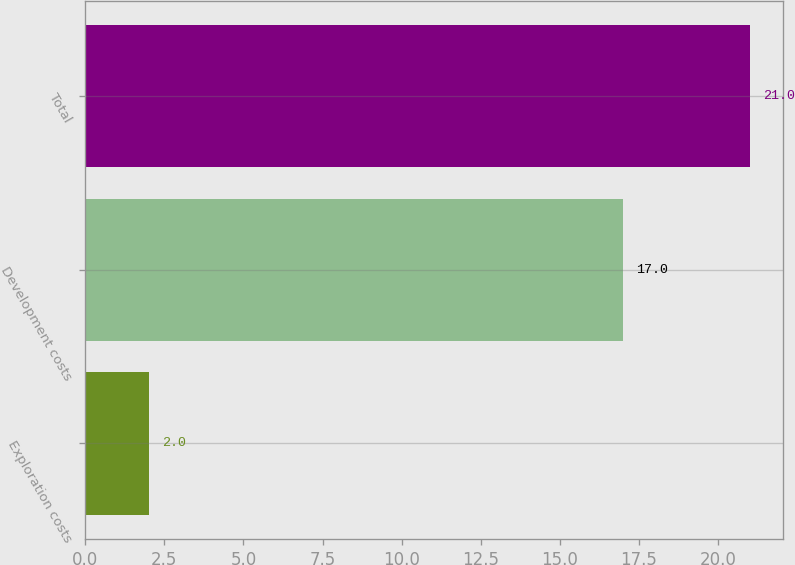Convert chart. <chart><loc_0><loc_0><loc_500><loc_500><bar_chart><fcel>Exploration costs<fcel>Development costs<fcel>Total<nl><fcel>2<fcel>17<fcel>21<nl></chart> 